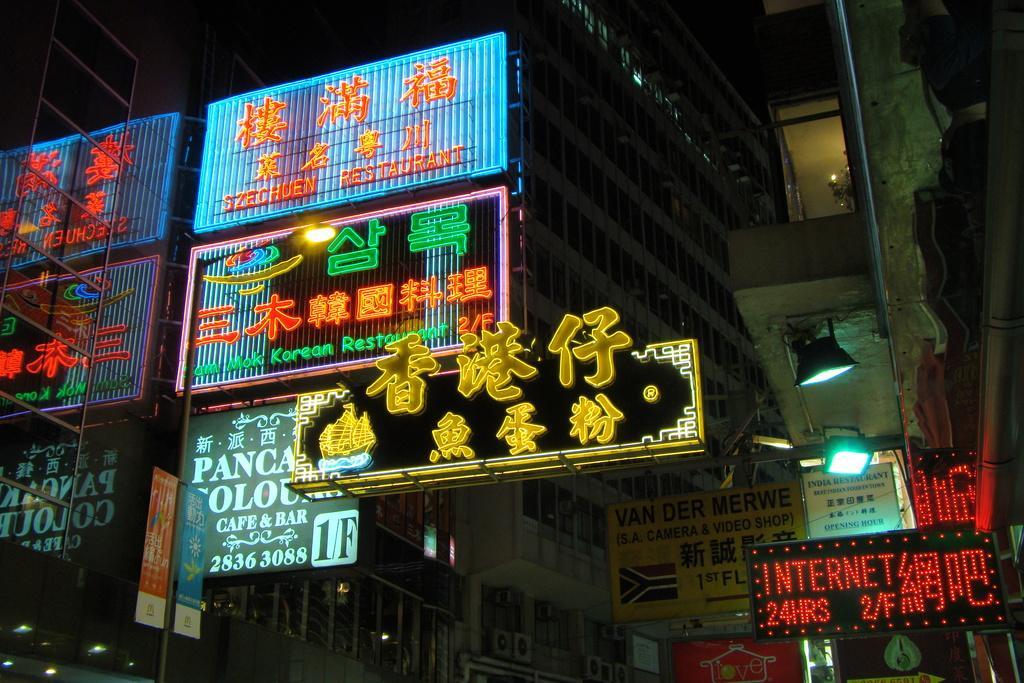In one or two sentences, can you explain what this image depicts? In this picture I can see some buildings, lighted boards and we can see some lights. 